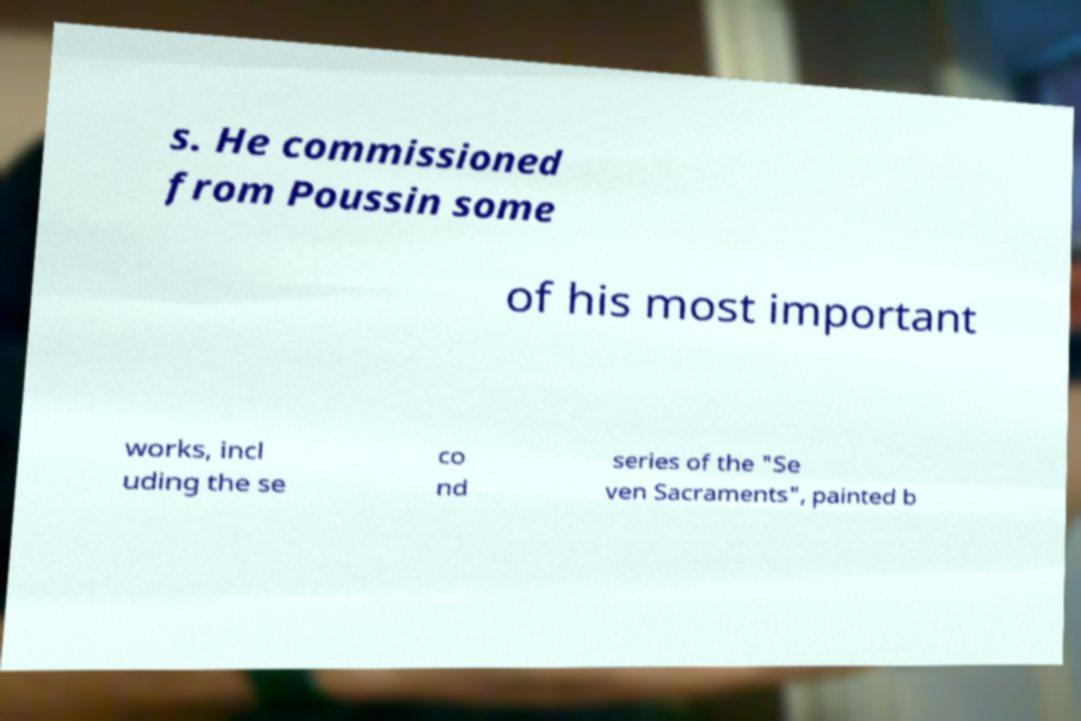Can you read and provide the text displayed in the image?This photo seems to have some interesting text. Can you extract and type it out for me? s. He commissioned from Poussin some of his most important works, incl uding the se co nd series of the "Se ven Sacraments", painted b 